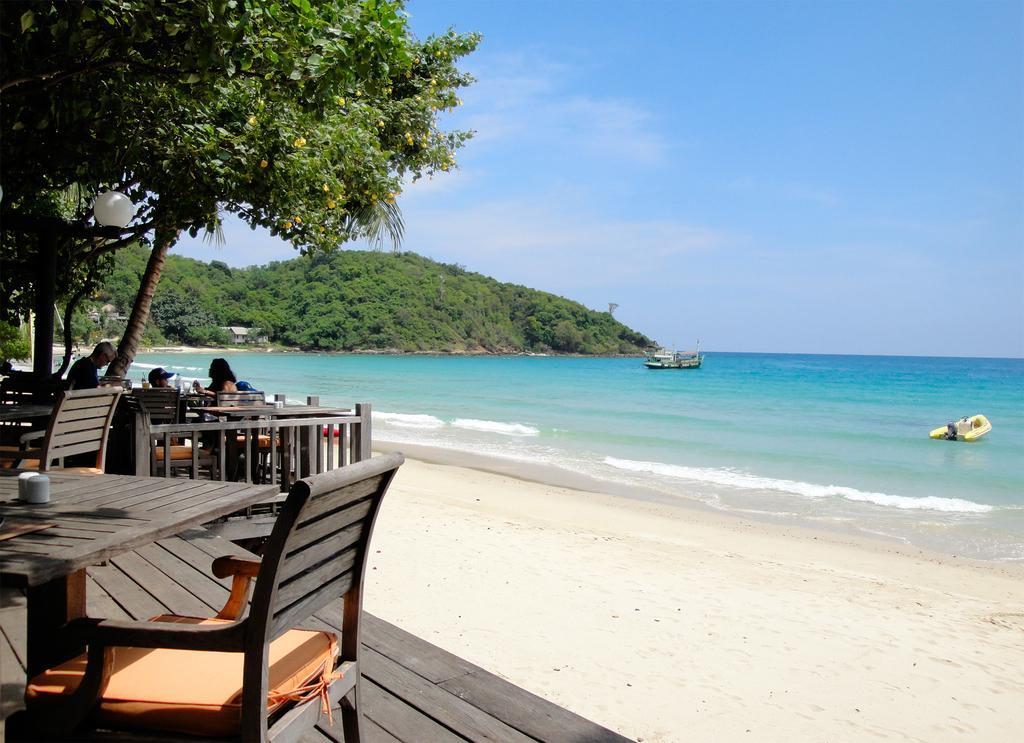Describe this image in one or two sentences. In the left side these are the chairs and dining tables, there are trees. In the right side few boats are sailing in the sea. 